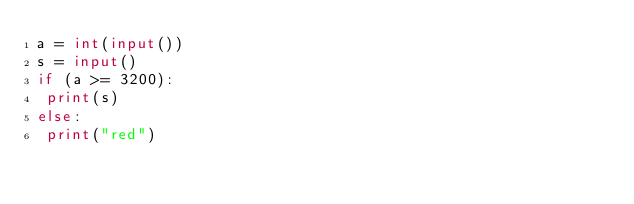Convert code to text. <code><loc_0><loc_0><loc_500><loc_500><_Python_>a = int(input())
s = input()
if (a >= 3200):
 print(s)
else:
 print("red")
</code> 